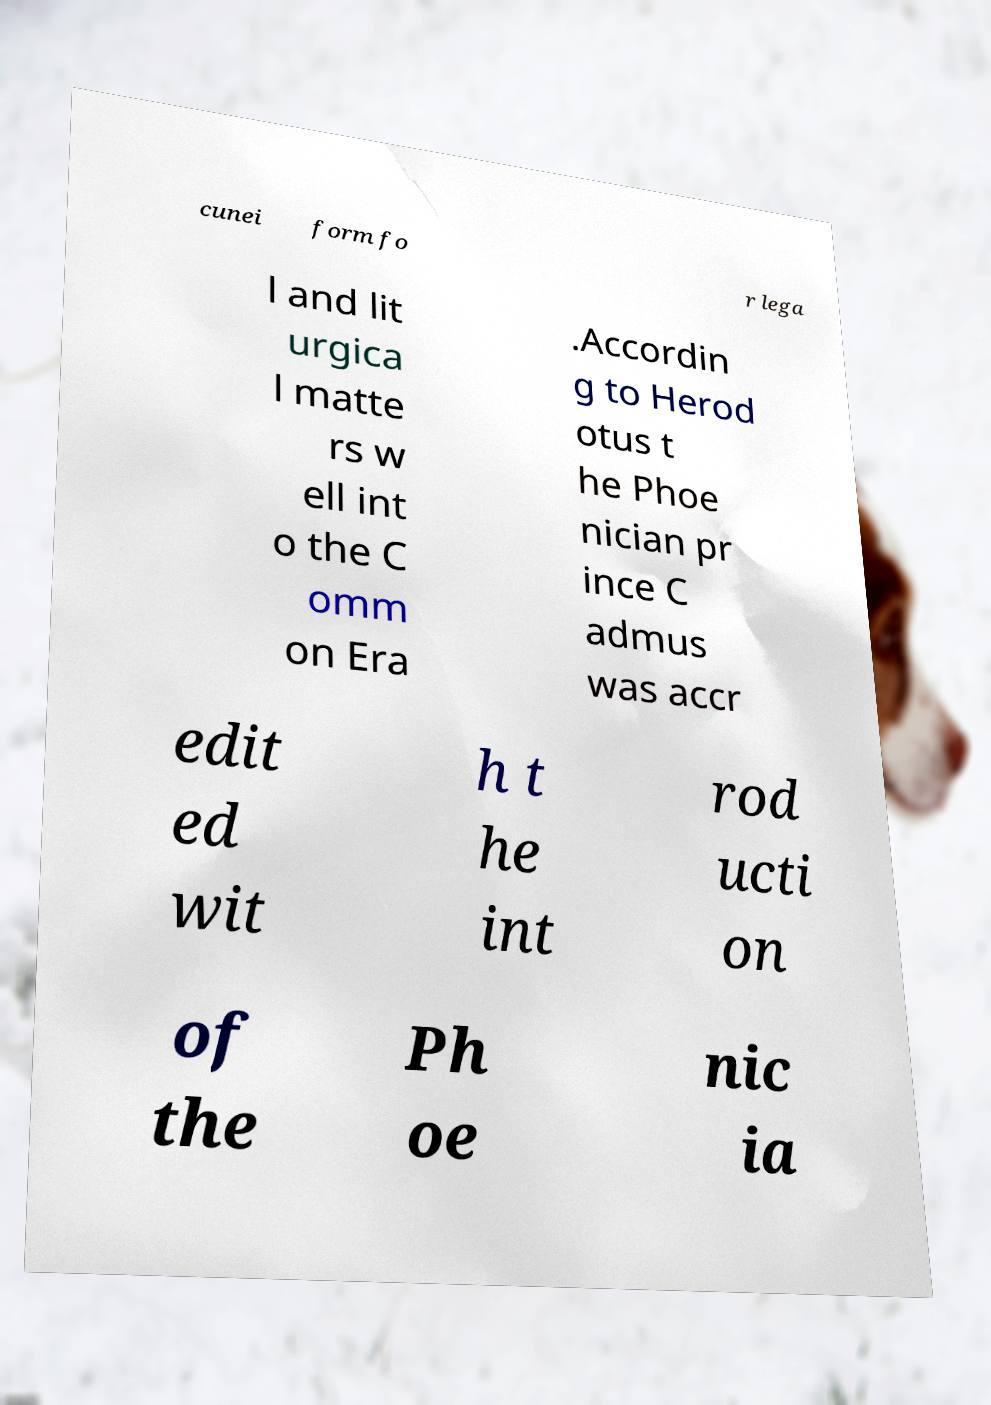I need the written content from this picture converted into text. Can you do that? cunei form fo r lega l and lit urgica l matte rs w ell int o the C omm on Era .Accordin g to Herod otus t he Phoe nician pr ince C admus was accr edit ed wit h t he int rod ucti on of the Ph oe nic ia 